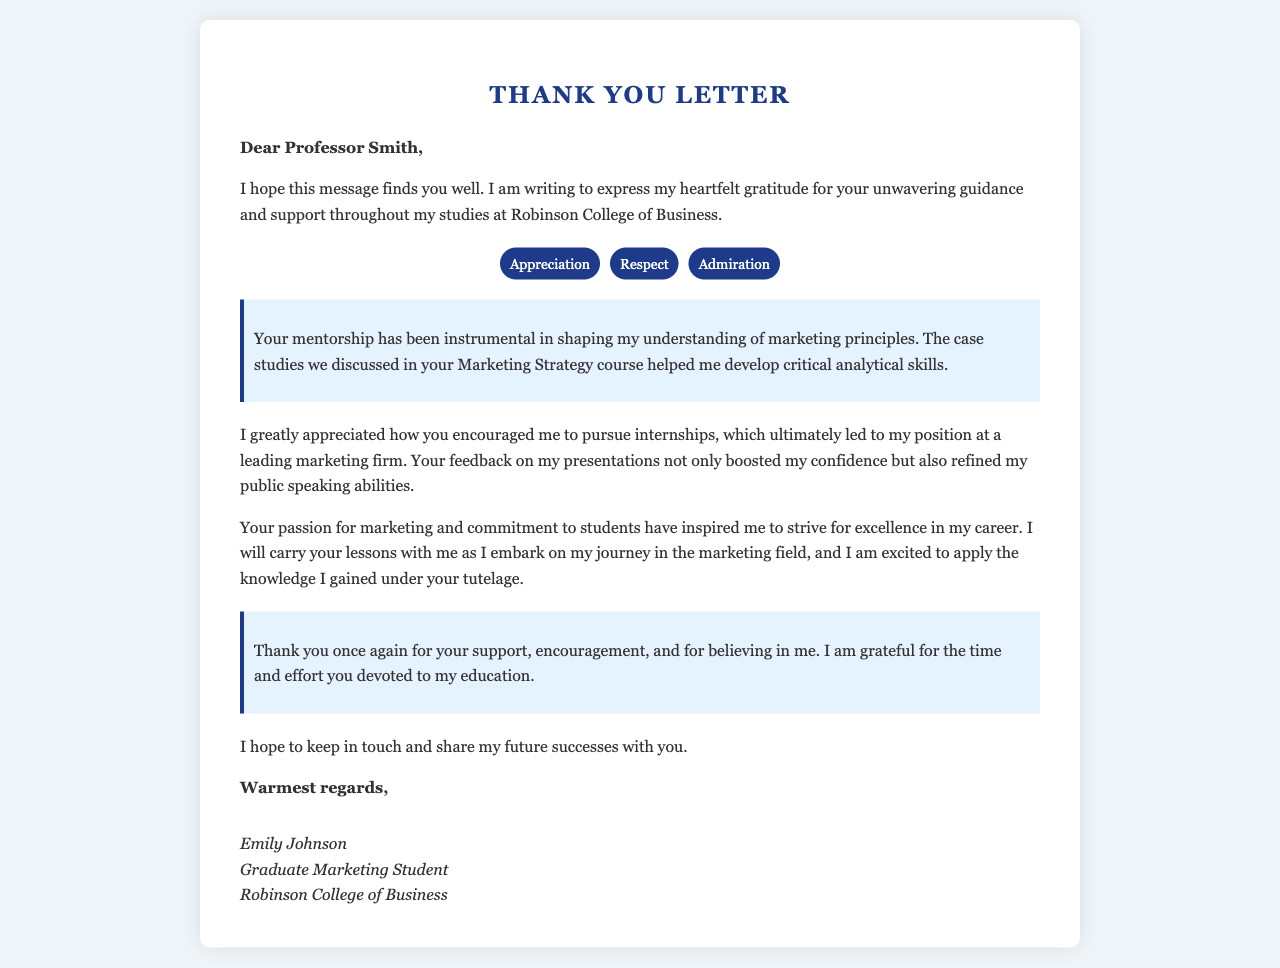What is the name of the professor addressed in the letter? The letter is addressed to Professor Smith, who is the person being thanked.
Answer: Professor Smith Which college is mentioned in the letter? The letter specifies that the author studied at Robinson College of Business.
Answer: Robinson College of Business What emotion is highlighted for the professor’s mentorship? The letter contains several emotions but highlights the appreciation for the mentorship provided.
Answer: Appreciation What course is referenced in the letter? The letter refers to the course about Marketing Strategy, which was significant in the author's studies.
Answer: Marketing Strategy How does the author feel about the professor's support? The author expresses gratitude for the support given during studies, indicating a positive impact on their education.
Answer: Grateful 